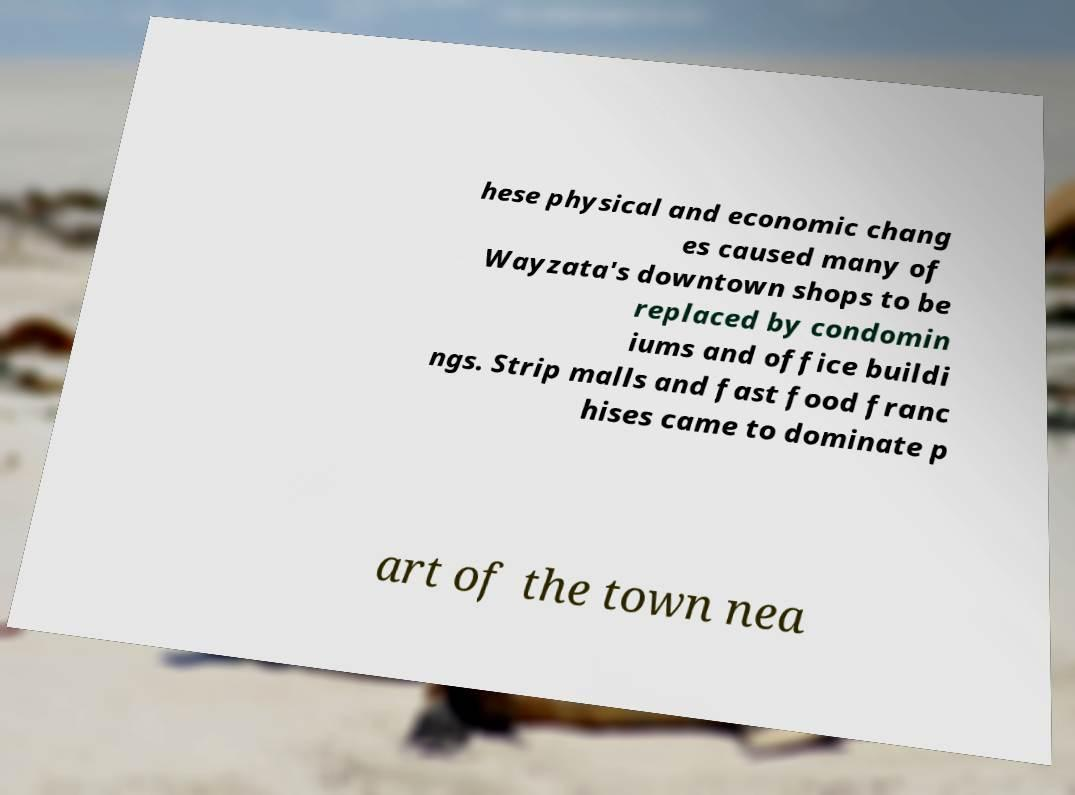Can you read and provide the text displayed in the image?This photo seems to have some interesting text. Can you extract and type it out for me? hese physical and economic chang es caused many of Wayzata's downtown shops to be replaced by condomin iums and office buildi ngs. Strip malls and fast food franc hises came to dominate p art of the town nea 